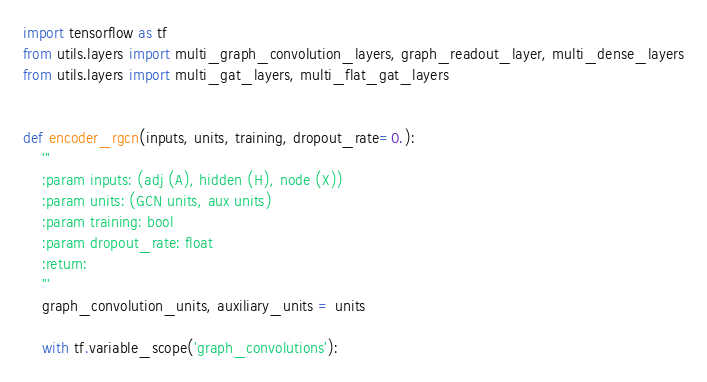<code> <loc_0><loc_0><loc_500><loc_500><_Python_>import tensorflow as tf
from utils.layers import multi_graph_convolution_layers, graph_readout_layer, multi_dense_layers
from utils.layers import multi_gat_layers, multi_flat_gat_layers


def encoder_rgcn(inputs, units, training, dropout_rate=0.):
    '''
    :param inputs: (adj (A), hidden (H), node (X))
    :param units: (GCN units, aux units)
    :param training: bool
    :param dropout_rate: float
    :return:
    '''
    graph_convolution_units, auxiliary_units = units

    with tf.variable_scope('graph_convolutions'):</code> 